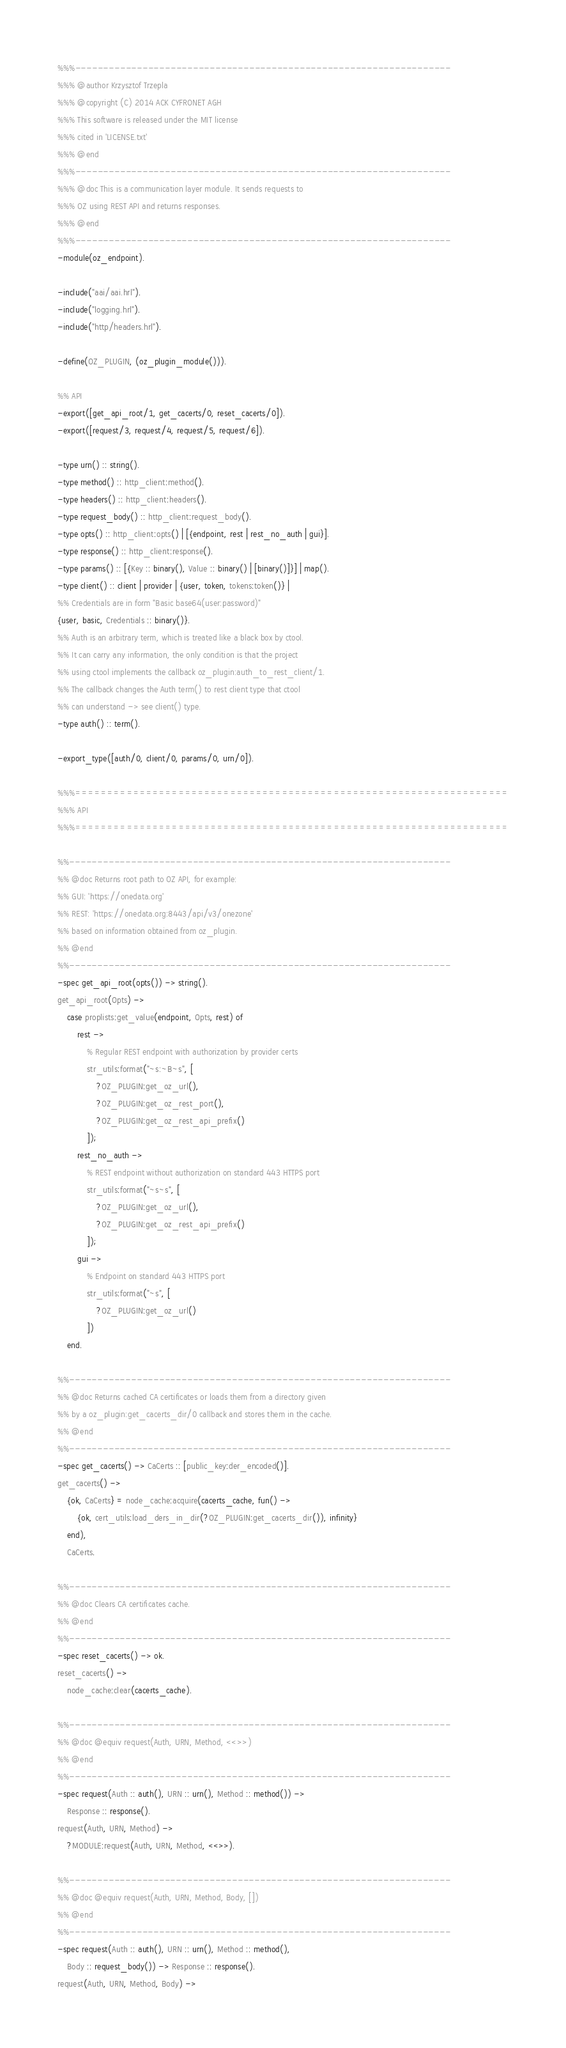Convert code to text. <code><loc_0><loc_0><loc_500><loc_500><_Erlang_>%%%-------------------------------------------------------------------
%%% @author Krzysztof Trzepla
%%% @copyright (C) 2014 ACK CYFRONET AGH
%%% This software is released under the MIT license
%%% cited in 'LICENSE.txt'
%%% @end
%%%-------------------------------------------------------------------
%%% @doc This is a communication layer module. It sends requests to
%%% OZ using REST API and returns responses.
%%% @end
%%%-------------------------------------------------------------------
-module(oz_endpoint).

-include("aai/aai.hrl").
-include("logging.hrl").
-include("http/headers.hrl").

-define(OZ_PLUGIN, (oz_plugin_module())).

%% API
-export([get_api_root/1, get_cacerts/0, reset_cacerts/0]).
-export([request/3, request/4, request/5, request/6]).

-type urn() :: string().
-type method() :: http_client:method().
-type headers() :: http_client:headers().
-type request_body() :: http_client:request_body().
-type opts() :: http_client:opts() | [{endpoint, rest | rest_no_auth | gui}].
-type response() :: http_client:response().
-type params() :: [{Key :: binary(), Value :: binary() | [binary()]}] | map().
-type client() :: client | provider | {user, token, tokens:token()} |
%% Credentials are in form "Basic base64(user:password)"
{user, basic, Credentials :: binary()}.
%% Auth is an arbitrary term, which is treated like a black box by ctool.
%% It can carry any information, the only condition is that the project
%% using ctool implements the callback oz_plugin:auth_to_rest_client/1.
%% The callback changes the Auth term() to rest client type that ctool
%% can understand -> see client() type.
-type auth() :: term().

-export_type([auth/0, client/0, params/0, urn/0]).

%%%===================================================================
%%% API
%%%===================================================================

%%--------------------------------------------------------------------
%% @doc Returns root path to OZ API, for example:
%% GUI: 'https://onedata.org'
%% REST: 'https://onedata.org:8443/api/v3/onezone'
%% based on information obtained from oz_plugin.
%% @end
%%--------------------------------------------------------------------
-spec get_api_root(opts()) -> string().
get_api_root(Opts) ->
    case proplists:get_value(endpoint, Opts, rest) of
        rest ->
            % Regular REST endpoint with authorization by provider certs
            str_utils:format("~s:~B~s", [
                ?OZ_PLUGIN:get_oz_url(),
                ?OZ_PLUGIN:get_oz_rest_port(),
                ?OZ_PLUGIN:get_oz_rest_api_prefix()
            ]);
        rest_no_auth ->
            % REST endpoint without authorization on standard 443 HTTPS port
            str_utils:format("~s~s", [
                ?OZ_PLUGIN:get_oz_url(),
                ?OZ_PLUGIN:get_oz_rest_api_prefix()
            ]);
        gui ->
            % Endpoint on standard 443 HTTPS port
            str_utils:format("~s", [
                ?OZ_PLUGIN:get_oz_url()
            ])
    end.

%%--------------------------------------------------------------------
%% @doc Returns cached CA certificates or loads them from a directory given
%% by a oz_plugin:get_cacerts_dir/0 callback and stores them in the cache.
%% @end
%%--------------------------------------------------------------------
-spec get_cacerts() -> CaCerts :: [public_key:der_encoded()].
get_cacerts() ->
    {ok, CaCerts} = node_cache:acquire(cacerts_cache, fun() ->
        {ok, cert_utils:load_ders_in_dir(?OZ_PLUGIN:get_cacerts_dir()), infinity}
    end),
    CaCerts.

%%--------------------------------------------------------------------
%% @doc Clears CA certificates cache.
%% @end
%%--------------------------------------------------------------------
-spec reset_cacerts() -> ok.
reset_cacerts() ->
    node_cache:clear(cacerts_cache).

%%--------------------------------------------------------------------
%% @doc @equiv request(Auth, URN, Method, <<>>)
%% @end
%%--------------------------------------------------------------------
-spec request(Auth :: auth(), URN :: urn(), Method :: method()) ->
    Response :: response().
request(Auth, URN, Method) ->
    ?MODULE:request(Auth, URN, Method, <<>>).

%%--------------------------------------------------------------------
%% @doc @equiv request(Auth, URN, Method, Body, [])
%% @end
%%--------------------------------------------------------------------
-spec request(Auth :: auth(), URN :: urn(), Method :: method(),
    Body :: request_body()) -> Response :: response().
request(Auth, URN, Method, Body) -></code> 